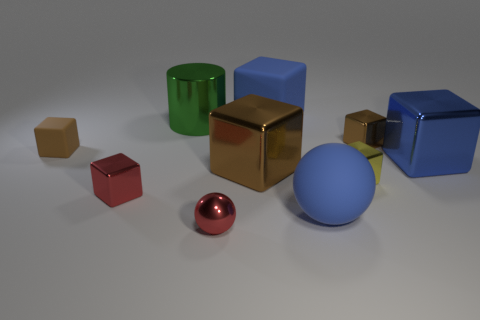What is the small sphere made of?
Your answer should be compact. Metal. What number of rubber things are the same size as the green cylinder?
Give a very brief answer. 2. The large metal thing that is the same color as the big sphere is what shape?
Keep it short and to the point. Cube. Are there any yellow metallic objects that have the same shape as the big brown thing?
Your answer should be very brief. Yes. The rubber block that is the same size as the red ball is what color?
Make the answer very short. Brown. What color is the tiny metallic block that is behind the brown object that is left of the big cylinder?
Your response must be concise. Brown. There is a small metal object behind the small brown rubber block; does it have the same color as the small rubber block?
Make the answer very short. Yes. What shape is the large blue rubber thing in front of the brown thing that is right of the matte cube behind the green metallic thing?
Provide a short and direct response. Sphere. How many large metal things are on the left side of the red thing on the right side of the small red cube?
Ensure brevity in your answer.  1. Is the big green object made of the same material as the large ball?
Provide a succinct answer. No. 